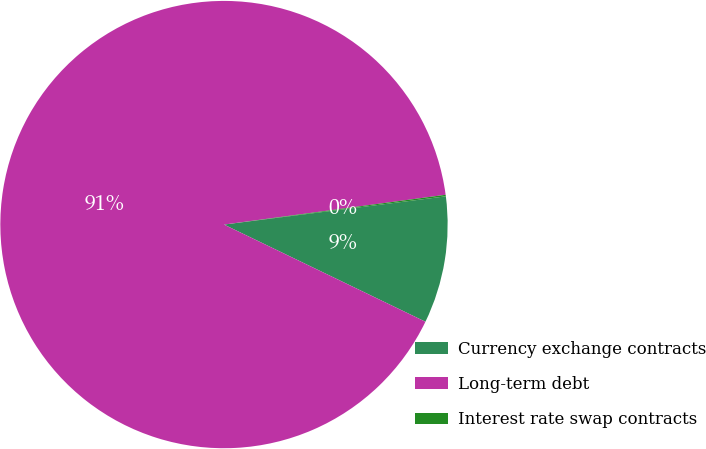Convert chart. <chart><loc_0><loc_0><loc_500><loc_500><pie_chart><fcel>Currency exchange contracts<fcel>Long-term debt<fcel>Interest rate swap contracts<nl><fcel>9.17%<fcel>90.72%<fcel>0.11%<nl></chart> 